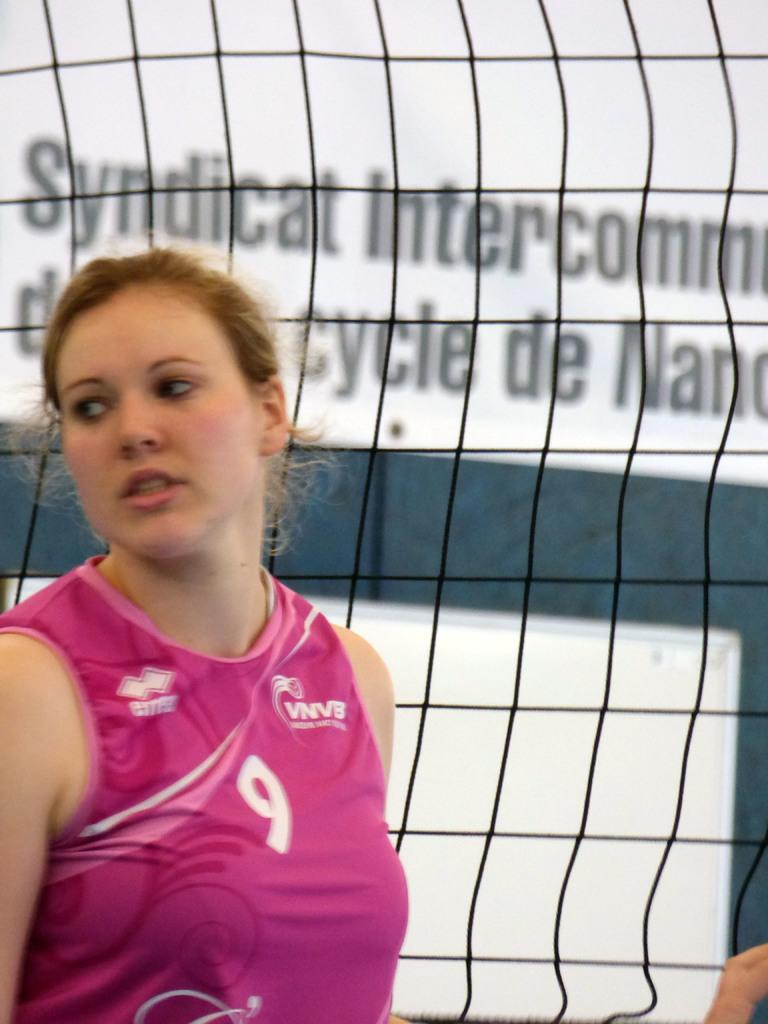Who is the main subject in the foreground of the image? There is a woman in the foreground of the image. What can be seen behind the woman? There is a net visible behind the woman. What type of rain is falling on the ducks in the image? There are no ducks or rain present in the image. 